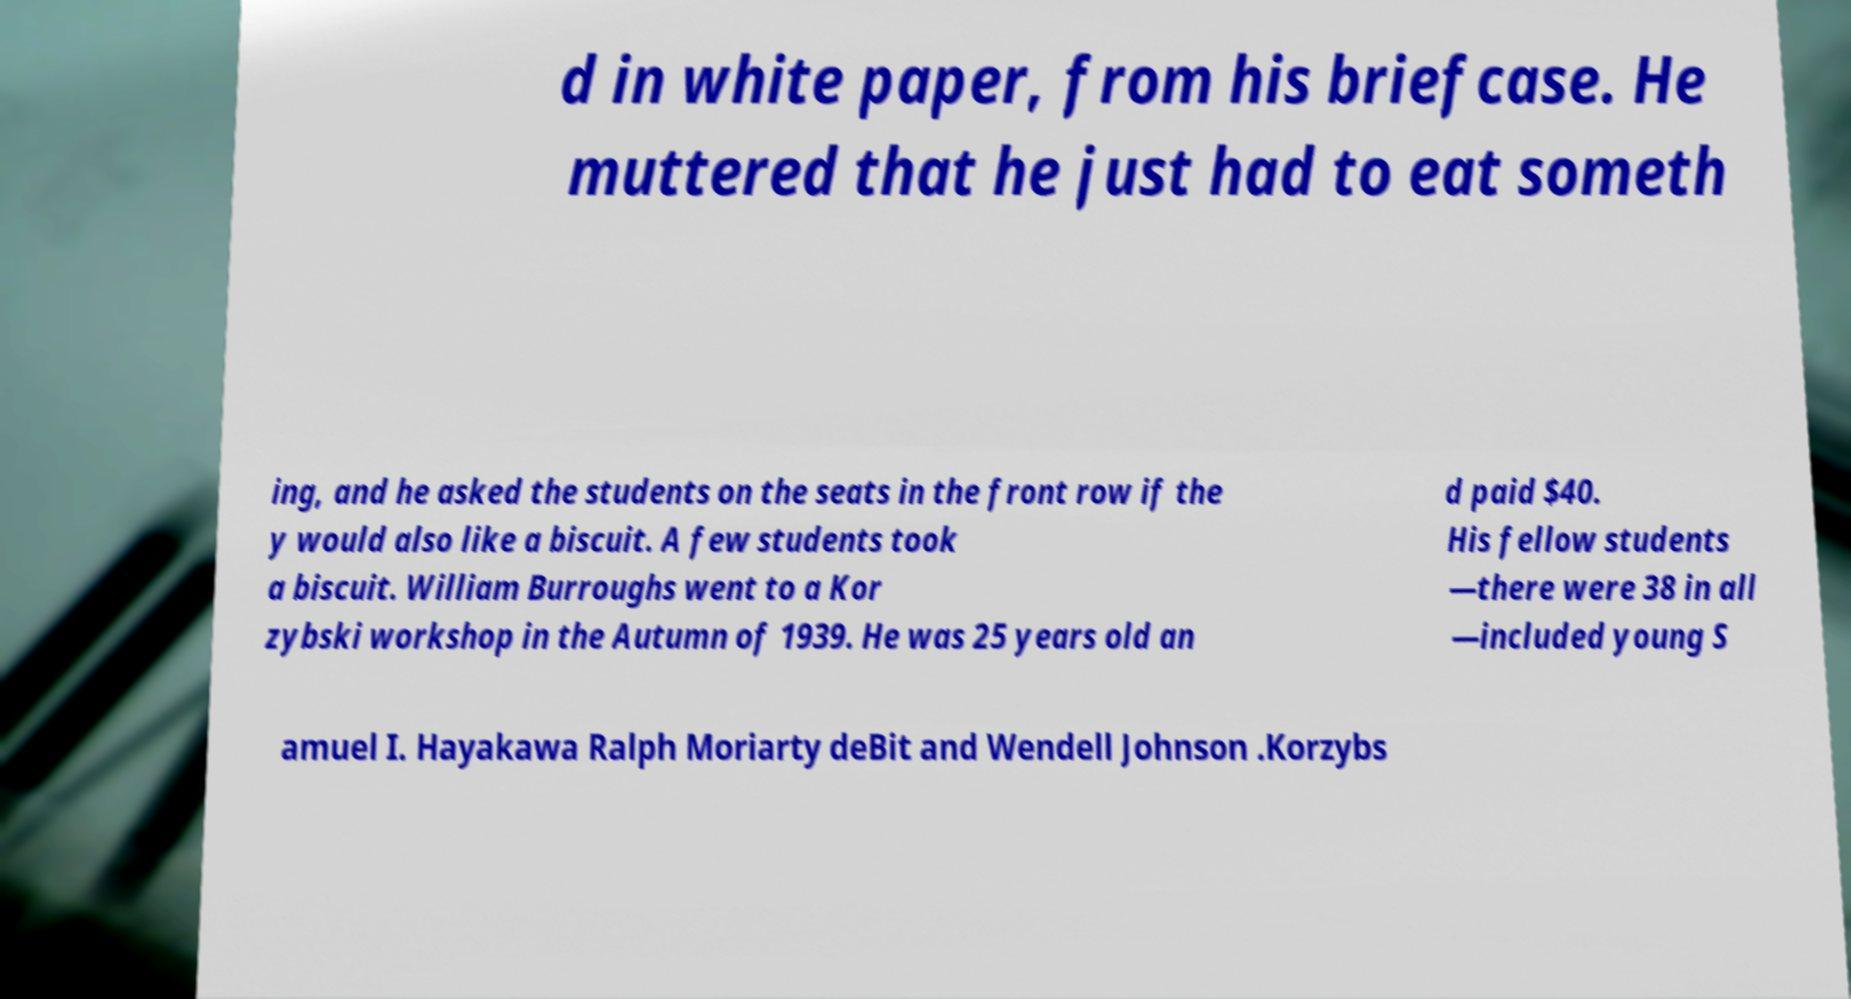There's text embedded in this image that I need extracted. Can you transcribe it verbatim? d in white paper, from his briefcase. He muttered that he just had to eat someth ing, and he asked the students on the seats in the front row if the y would also like a biscuit. A few students took a biscuit. William Burroughs went to a Kor zybski workshop in the Autumn of 1939. He was 25 years old an d paid $40. His fellow students —there were 38 in all —included young S amuel I. Hayakawa Ralph Moriarty deBit and Wendell Johnson .Korzybs 